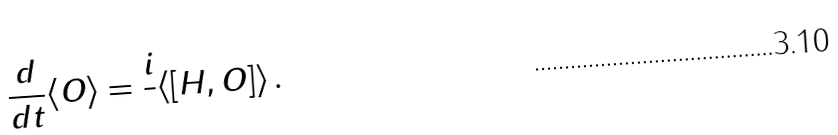<formula> <loc_0><loc_0><loc_500><loc_500>\frac { d } { d t } \langle O \rangle = \frac { i } { } \langle [ H , O ] \rangle \, .</formula> 